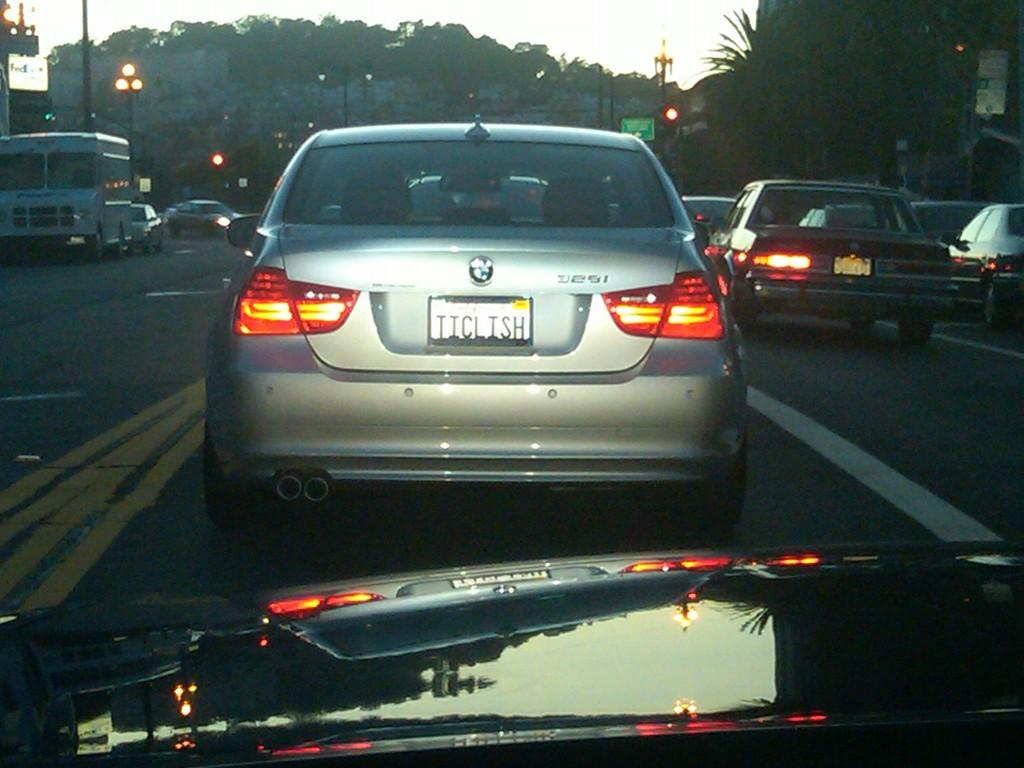<image>
Share a concise interpretation of the image provided. Silver car with a license plate that says TICLISH. 